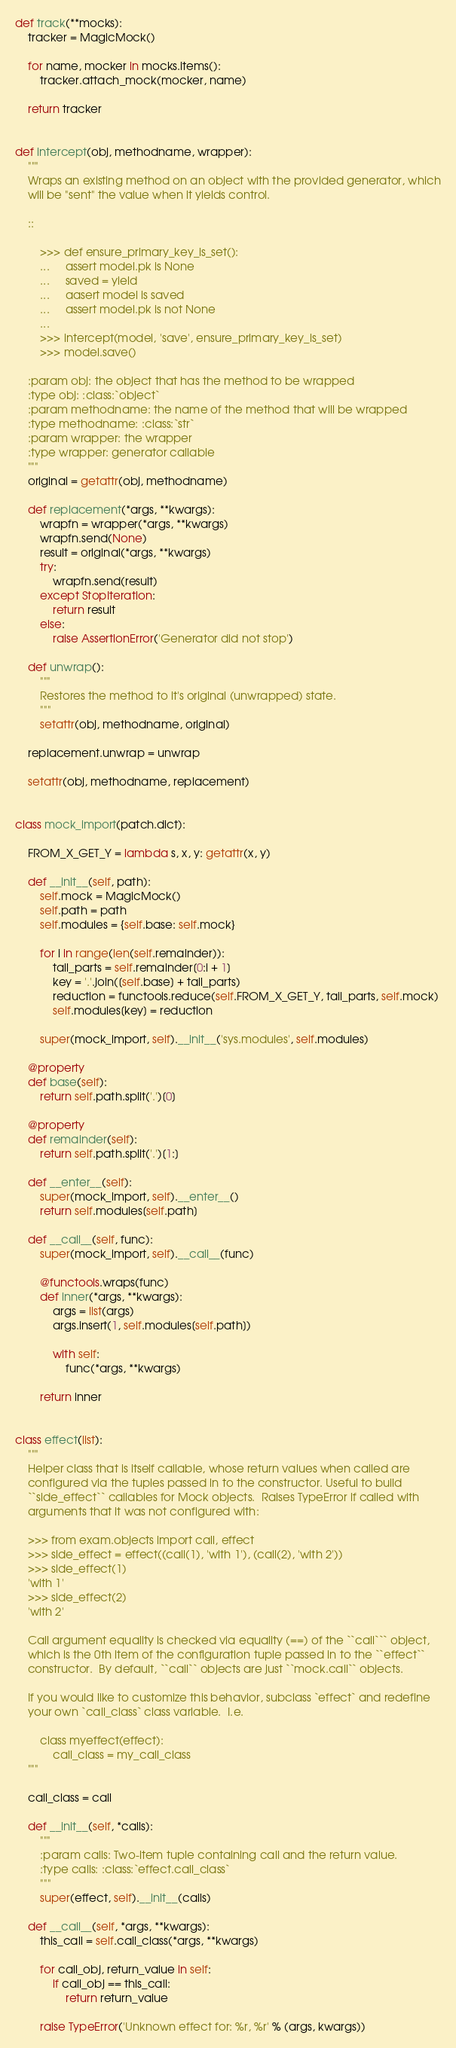<code> <loc_0><loc_0><loc_500><loc_500><_Python_>

def track(**mocks):
    tracker = MagicMock()

    for name, mocker in mocks.items():
        tracker.attach_mock(mocker, name)

    return tracker


def intercept(obj, methodname, wrapper):
    """
    Wraps an existing method on an object with the provided generator, which
    will be "sent" the value when it yields control.

    ::

        >>> def ensure_primary_key_is_set():
        ...     assert model.pk is None
        ...     saved = yield
        ...     aasert model is saved
        ...     assert model.pk is not None
        ...
        >>> intercept(model, 'save', ensure_primary_key_is_set)
        >>> model.save()

    :param obj: the object that has the method to be wrapped
    :type obj: :class:`object`
    :param methodname: the name of the method that will be wrapped
    :type methodname: :class:`str`
    :param wrapper: the wrapper
    :type wrapper: generator callable
    """
    original = getattr(obj, methodname)

    def replacement(*args, **kwargs):
        wrapfn = wrapper(*args, **kwargs)
        wrapfn.send(None)
        result = original(*args, **kwargs)
        try:
            wrapfn.send(result)
        except StopIteration:
            return result
        else:
            raise AssertionError('Generator did not stop')

    def unwrap():
        """
        Restores the method to it's original (unwrapped) state.
        """
        setattr(obj, methodname, original)

    replacement.unwrap = unwrap

    setattr(obj, methodname, replacement)


class mock_import(patch.dict):

    FROM_X_GET_Y = lambda s, x, y: getattr(x, y)

    def __init__(self, path):
        self.mock = MagicMock()
        self.path = path
        self.modules = {self.base: self.mock}

        for i in range(len(self.remainder)):
            tail_parts = self.remainder[0:i + 1]
            key = '.'.join([self.base] + tail_parts)
            reduction = functools.reduce(self.FROM_X_GET_Y, tail_parts, self.mock)
            self.modules[key] = reduction

        super(mock_import, self).__init__('sys.modules', self.modules)

    @property
    def base(self):
        return self.path.split('.')[0]

    @property
    def remainder(self):
        return self.path.split('.')[1:]

    def __enter__(self):
        super(mock_import, self).__enter__()
        return self.modules[self.path]

    def __call__(self, func):
        super(mock_import, self).__call__(func)

        @functools.wraps(func)
        def inner(*args, **kwargs):
            args = list(args)
            args.insert(1, self.modules[self.path])

            with self:
                func(*args, **kwargs)

        return inner


class effect(list):
    """
    Helper class that is itself callable, whose return values when called are
    configured via the tuples passed in to the constructor. Useful to build
    ``side_effect`` callables for Mock objects.  Raises TypeError if called with
    arguments that it was not configured with:

    >>> from exam.objects import call, effect
    >>> side_effect = effect((call(1), 'with 1'), (call(2), 'with 2'))
    >>> side_effect(1)
    'with 1'
    >>> side_effect(2)
    'with 2'

    Call argument equality is checked via equality (==) of the ``call``` object,
    which is the 0th item of the configuration tuple passed in to the ``effect``
    constructor.  By default, ``call`` objects are just ``mock.call`` objects.

    If you would like to customize this behavior, subclass `effect` and redefine
    your own `call_class` class variable.  I.e.

        class myeffect(effect):
            call_class = my_call_class
    """

    call_class = call

    def __init__(self, *calls):
        """
        :param calls: Two-item tuple containing call and the return value.
        :type calls: :class:`effect.call_class`
        """
        super(effect, self).__init__(calls)

    def __call__(self, *args, **kwargs):
        this_call = self.call_class(*args, **kwargs)

        for call_obj, return_value in self:
            if call_obj == this_call:
                return return_value

        raise TypeError('Unknown effect for: %r, %r' % (args, kwargs))

</code> 